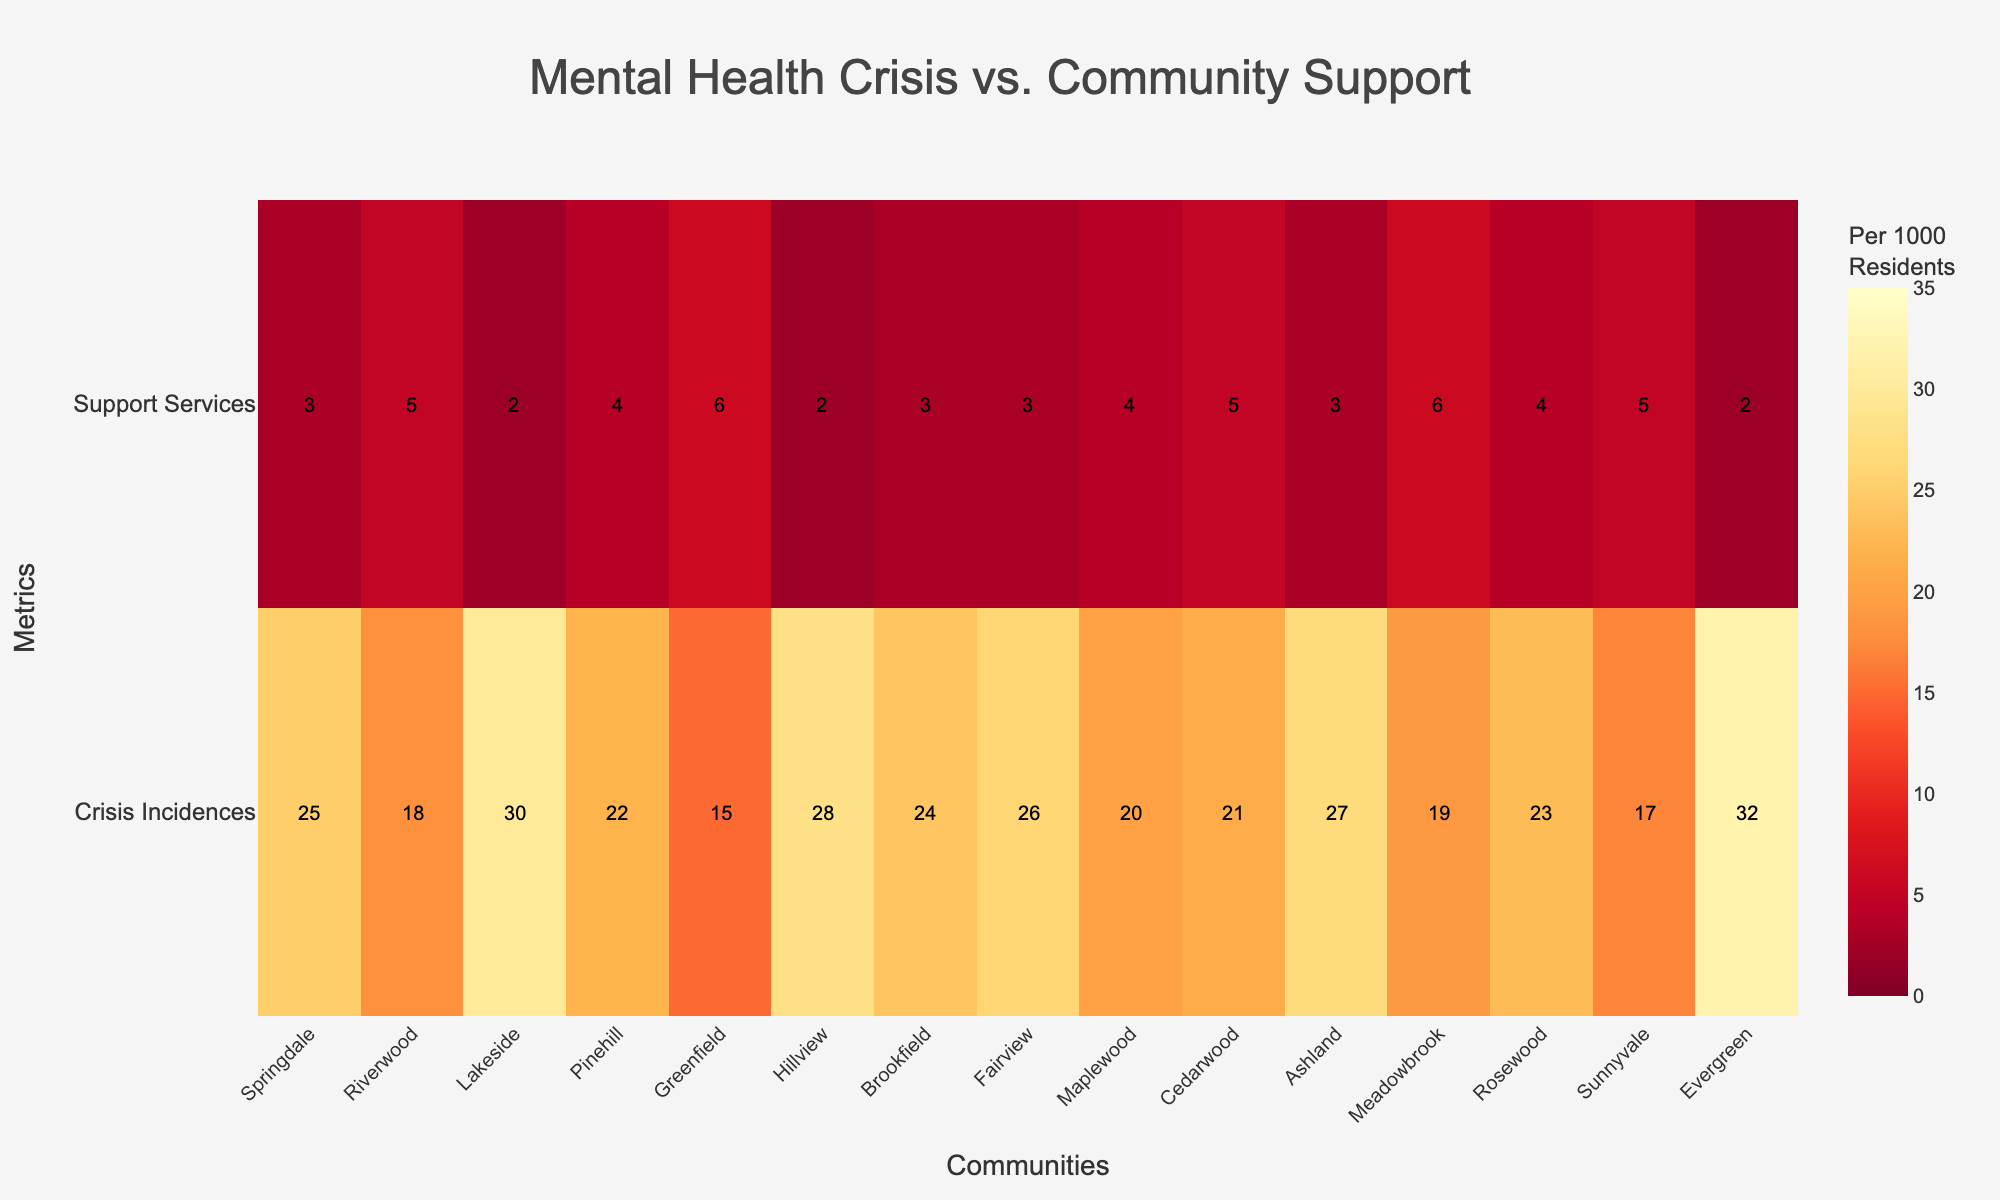Which community has the highest number of mental health crisis incidences per 1000 residents? The figure shows values for each community. By looking at the "Crisis Incidences" row, identify the highest value. Evergreen has the highest value with 32 incidences.
Answer: Evergreen How many communities have an availability of community support services greater than 4 per 1000 residents? The figure displays values for support services. Count the number of communities where the "Support Services" row shows values greater than 4. This applies to Riverwood, Greenfield, Cedarwood, Meadowbrook, and Sunnyvale, totaling 5 communities.
Answer: 5 Which community has the lowest availability of community support services per 1000 residents? Review the values in the "Support Services" row for the minimum value. Both Lakeside, Hillview, and Evergreen have the lowest availability with 2 services per 1000 residents.
Answer: Lakeside or Hillview or Evergreen What is the range of mental health crisis incidences per 1000 residents among all communities? Identify the maximum and minimum values in the "Crisis Incidences" row and calculate the difference between them. The maximum is 32 (Evergreen), and the minimum is 15 (Greenfield), so the range is 32 - 15 = 17.
Answer: 17 Which community has the same number of mental health crisis incidences and availability of community support services? Locate a community where the values in the "Crisis Incidences" and "Support Services" rows are equal. There are no communities where the values match exactly.
Answer: None How do mental health crisis incidences and availability of support services compare in Riverwood? Refer to the figure and compare the two values in Riverwood. Riverwood has 18 crisis incidences and 5 support services.
Answer: 18 (crisis incidences), 5 (support services) Which community has the second highest number of mental health crisis incidences? Find the highest value in the "Crisis Incidences" row, then locate the second-highest value. The second-highest value after 32 (Evergreen) is 30 (Lakeside).
Answer: Lakeside Is there a general trend between mental health crisis incidences and availability of support services among the communities? Observing the heatmap visually, identify if there is an apparent trend where higher crisis incidences correlate with higher or lower support services. There is no clear trend; some communities with high crisis incidences have low support services and vice versa.
Answer: No clear trend What is the color scheme used in the heatmap? The heatmap uses a gradient color scheme from yellow to red (YlOrRd), where higher values are shown in darker reds, and lower values in lighter yellows.
Answer: Yellow to Red gradient Between Brookfield and Fairview, which community has higher mental health crisis incidences, and which has more support services? Compare the values for both communities in the "Crisis Incidences" and "Support Services" rows. Brookfield has 24 incidences and 3 services. Fairview has 26 incidences and 3 services. Fairview has higher incidences; both have the same support services.
Answer: Fairview (higher incidences), both have 3 services 